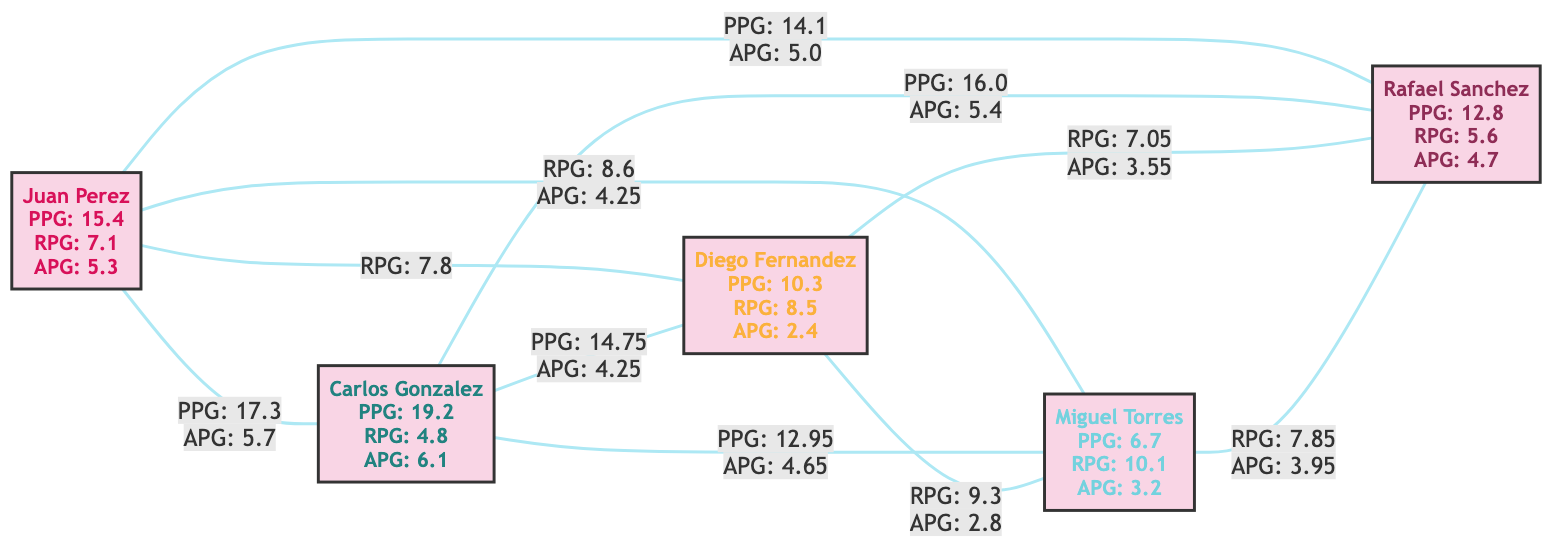What are the points per game of Juan Perez? The diagram indicates that Juan Perez has 15.4 points per game, which is displayed alongside his metrics.
Answer: 15.4 Which player has the highest rebounds per game? By comparing all the nodes' rebounds per game metrics, Miguel Torres scores the highest at 10.1, as shown in his node description.
Answer: 10.1 How many total edges are represented in the graph? The diagram displays a total of 10 edges connecting different players, indicating their performance relationships. This can be counted directly from the edges list.
Answer: 10 What is the average points per game shared between Juan Perez and Carlos Gonzalez? The shared metric of points per game between Juan Perez and Carlos Gonzalez is 17.3. This is directly noted on the edge connecting their nodes.
Answer: 17.3 What shared assists per game do Diego Fernandez and Miguel Torres have? The relationship edge connecting Diego Fernandez and Miguel Torres shows shared assists per game of 2.8, which is explicitly stated in the graph.
Answer: 2.8 Which two players share the highest assists per game? The shared assists per game between Carlos Gonzalez and Rafael Sanchez is 5.4, indicating that they have the highest assists collaboration in the graph.
Answer: 5.4 What is the relationship type for the player connection between Juan Perez and Diego Fernandez? The relationship noted on the edge shows they share rebounds per game as the only metric, highlighting their collaborative performance in that aspect.
Answer: Rebounds per game Which player has the fewest points per game? Among all the players, Miguel Torres has the lowest points per game, recorded at 6.7, as stated in his statistics.
Answer: 6.7 Do Carlos Gonzalez and Diego Fernandez have any shared metrics? According to the edge connecting them, they share both points per game and assists per game, evidenced by the values displayed on the edge.
Answer: Yes 